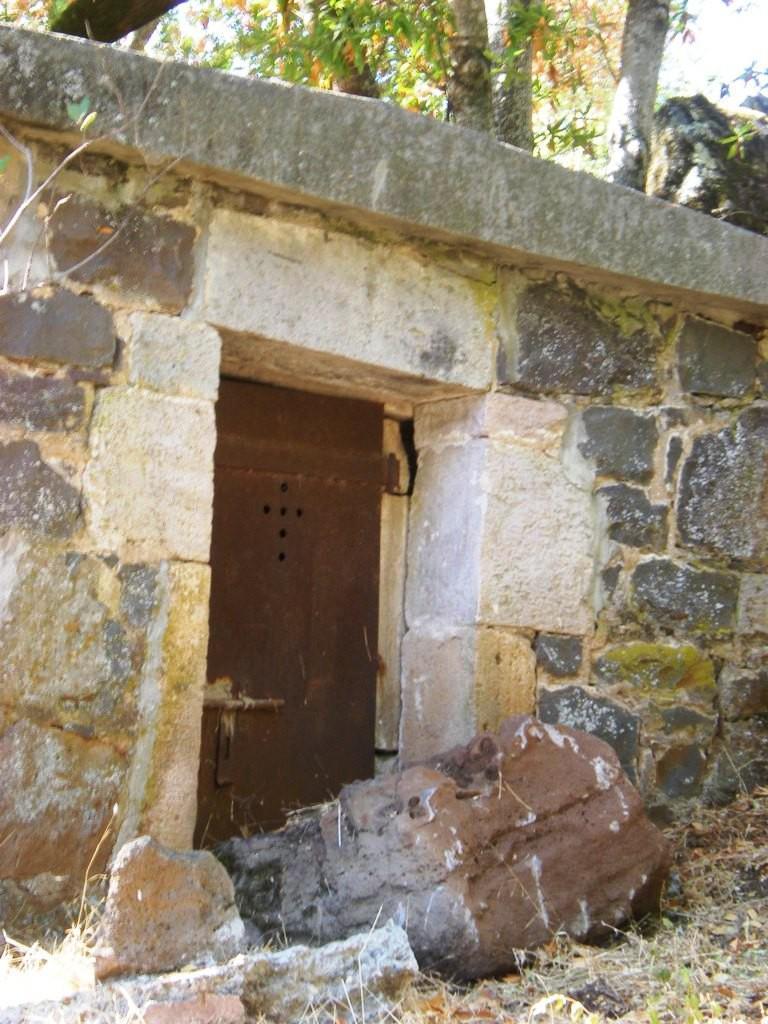How would you summarize this image in a sentence or two? In this image I can see a door to a wall. At the bottom there are few stones placed on the ground. At the top of the image there are few trees. 